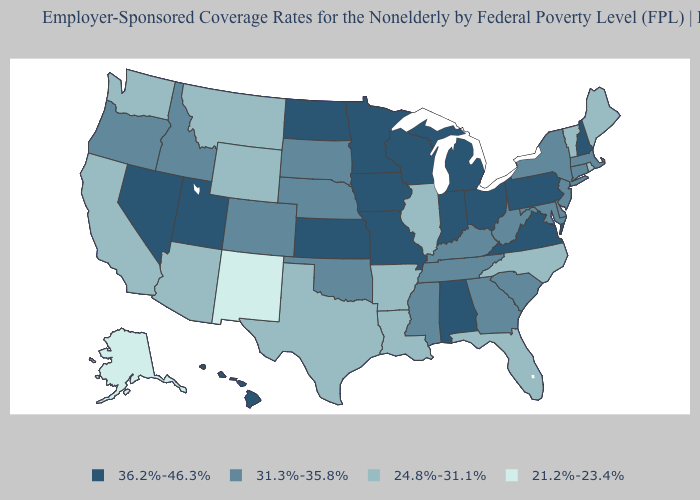Which states have the highest value in the USA?
Answer briefly. Alabama, Hawaii, Indiana, Iowa, Kansas, Michigan, Minnesota, Missouri, Nevada, New Hampshire, North Dakota, Ohio, Pennsylvania, Utah, Virginia, Wisconsin. Does New Jersey have the lowest value in the USA?
Be succinct. No. Among the states that border Kentucky , which have the lowest value?
Short answer required. Illinois. How many symbols are there in the legend?
Be succinct. 4. What is the highest value in states that border New York?
Give a very brief answer. 36.2%-46.3%. What is the value of Florida?
Keep it brief. 24.8%-31.1%. Among the states that border Wyoming , does Idaho have the lowest value?
Be succinct. No. Does Kansas have a higher value than New Hampshire?
Be succinct. No. What is the value of California?
Concise answer only. 24.8%-31.1%. What is the lowest value in states that border Arizona?
Keep it brief. 21.2%-23.4%. What is the value of Arizona?
Keep it brief. 24.8%-31.1%. Does Hawaii have a higher value than Rhode Island?
Short answer required. Yes. What is the value of Alaska?
Be succinct. 21.2%-23.4%. What is the value of New Hampshire?
Quick response, please. 36.2%-46.3%. Which states have the lowest value in the USA?
Short answer required. Alaska, New Mexico. 